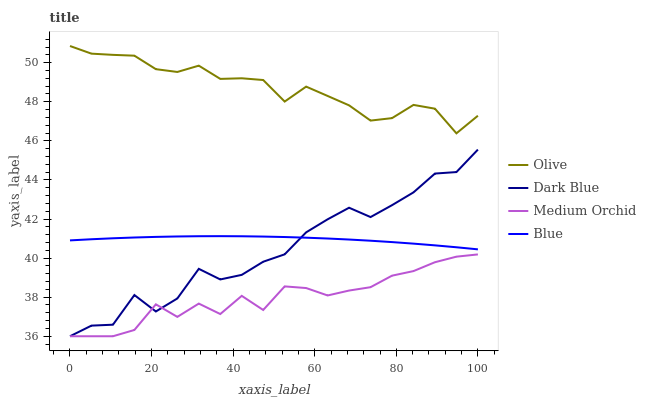Does Medium Orchid have the minimum area under the curve?
Answer yes or no. Yes. Does Olive have the maximum area under the curve?
Answer yes or no. Yes. Does Dark Blue have the minimum area under the curve?
Answer yes or no. No. Does Dark Blue have the maximum area under the curve?
Answer yes or no. No. Is Blue the smoothest?
Answer yes or no. Yes. Is Dark Blue the roughest?
Answer yes or no. Yes. Is Medium Orchid the smoothest?
Answer yes or no. No. Is Medium Orchid the roughest?
Answer yes or no. No. Does Dark Blue have the lowest value?
Answer yes or no. Yes. Does Blue have the lowest value?
Answer yes or no. No. Does Olive have the highest value?
Answer yes or no. Yes. Does Dark Blue have the highest value?
Answer yes or no. No. Is Medium Orchid less than Olive?
Answer yes or no. Yes. Is Olive greater than Dark Blue?
Answer yes or no. Yes. Does Medium Orchid intersect Dark Blue?
Answer yes or no. Yes. Is Medium Orchid less than Dark Blue?
Answer yes or no. No. Is Medium Orchid greater than Dark Blue?
Answer yes or no. No. Does Medium Orchid intersect Olive?
Answer yes or no. No. 